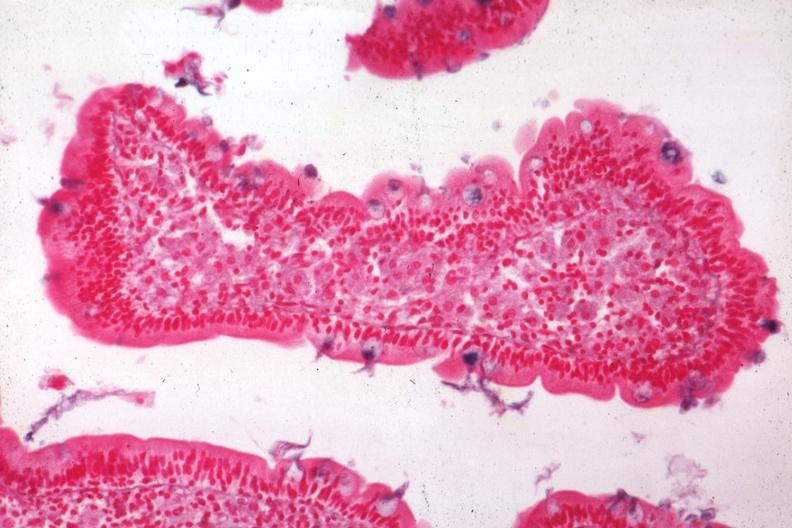s intestine present?
Answer the question using a single word or phrase. Yes 